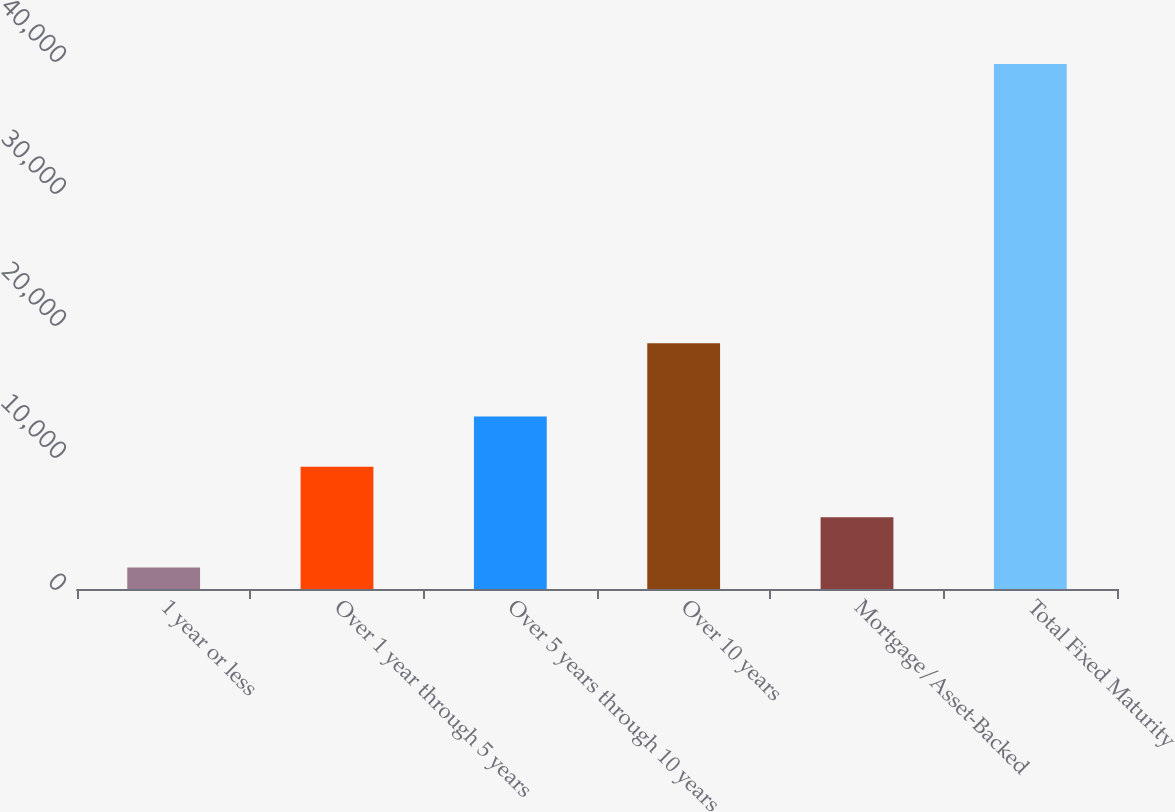Convert chart to OTSL. <chart><loc_0><loc_0><loc_500><loc_500><bar_chart><fcel>1 year or less<fcel>Over 1 year through 5 years<fcel>Over 5 years through 10 years<fcel>Over 10 years<fcel>Mortgage/Asset-Backed<fcel>Total Fixed Maturity<nl><fcel>1625.1<fcel>9256.18<fcel>13071.7<fcel>18611.2<fcel>5440.64<fcel>39780.5<nl></chart> 